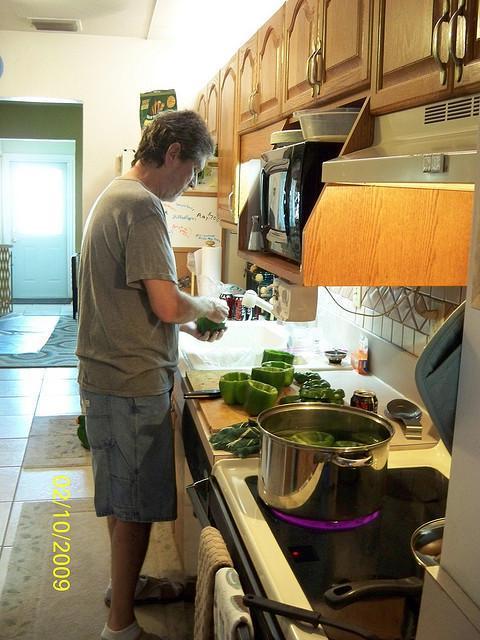How many people can be seen in the kitchen?
Give a very brief answer. 1. How many people are in the kitchen?
Give a very brief answer. 1. How many sinks are visible?
Give a very brief answer. 1. How many ovens can be seen?
Give a very brief answer. 1. How many boats can be seen?
Give a very brief answer. 0. 